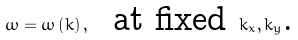Convert formula to latex. <formula><loc_0><loc_0><loc_500><loc_500>\omega = \omega \left ( k \right ) , \text {\ \ at fixed } k _ { x } , k _ { y } \text {.}</formula> 